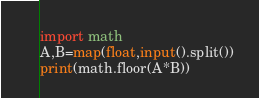<code> <loc_0><loc_0><loc_500><loc_500><_Python_>import math
A,B=map(float,input().split())
print(math.floor(A*B))</code> 